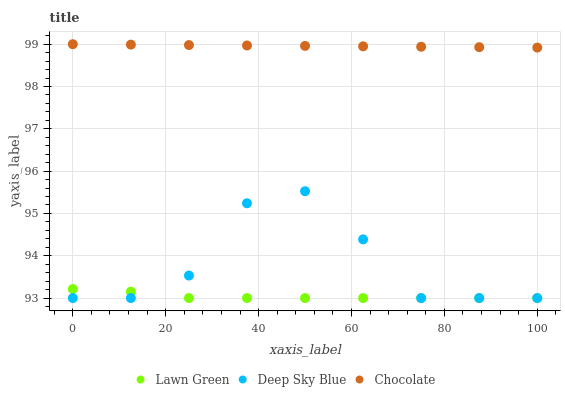Does Lawn Green have the minimum area under the curve?
Answer yes or no. Yes. Does Chocolate have the maximum area under the curve?
Answer yes or no. Yes. Does Deep Sky Blue have the minimum area under the curve?
Answer yes or no. No. Does Deep Sky Blue have the maximum area under the curve?
Answer yes or no. No. Is Chocolate the smoothest?
Answer yes or no. Yes. Is Deep Sky Blue the roughest?
Answer yes or no. Yes. Is Deep Sky Blue the smoothest?
Answer yes or no. No. Is Chocolate the roughest?
Answer yes or no. No. Does Lawn Green have the lowest value?
Answer yes or no. Yes. Does Chocolate have the lowest value?
Answer yes or no. No. Does Chocolate have the highest value?
Answer yes or no. Yes. Does Deep Sky Blue have the highest value?
Answer yes or no. No. Is Deep Sky Blue less than Chocolate?
Answer yes or no. Yes. Is Chocolate greater than Deep Sky Blue?
Answer yes or no. Yes. Does Lawn Green intersect Deep Sky Blue?
Answer yes or no. Yes. Is Lawn Green less than Deep Sky Blue?
Answer yes or no. No. Is Lawn Green greater than Deep Sky Blue?
Answer yes or no. No. Does Deep Sky Blue intersect Chocolate?
Answer yes or no. No. 